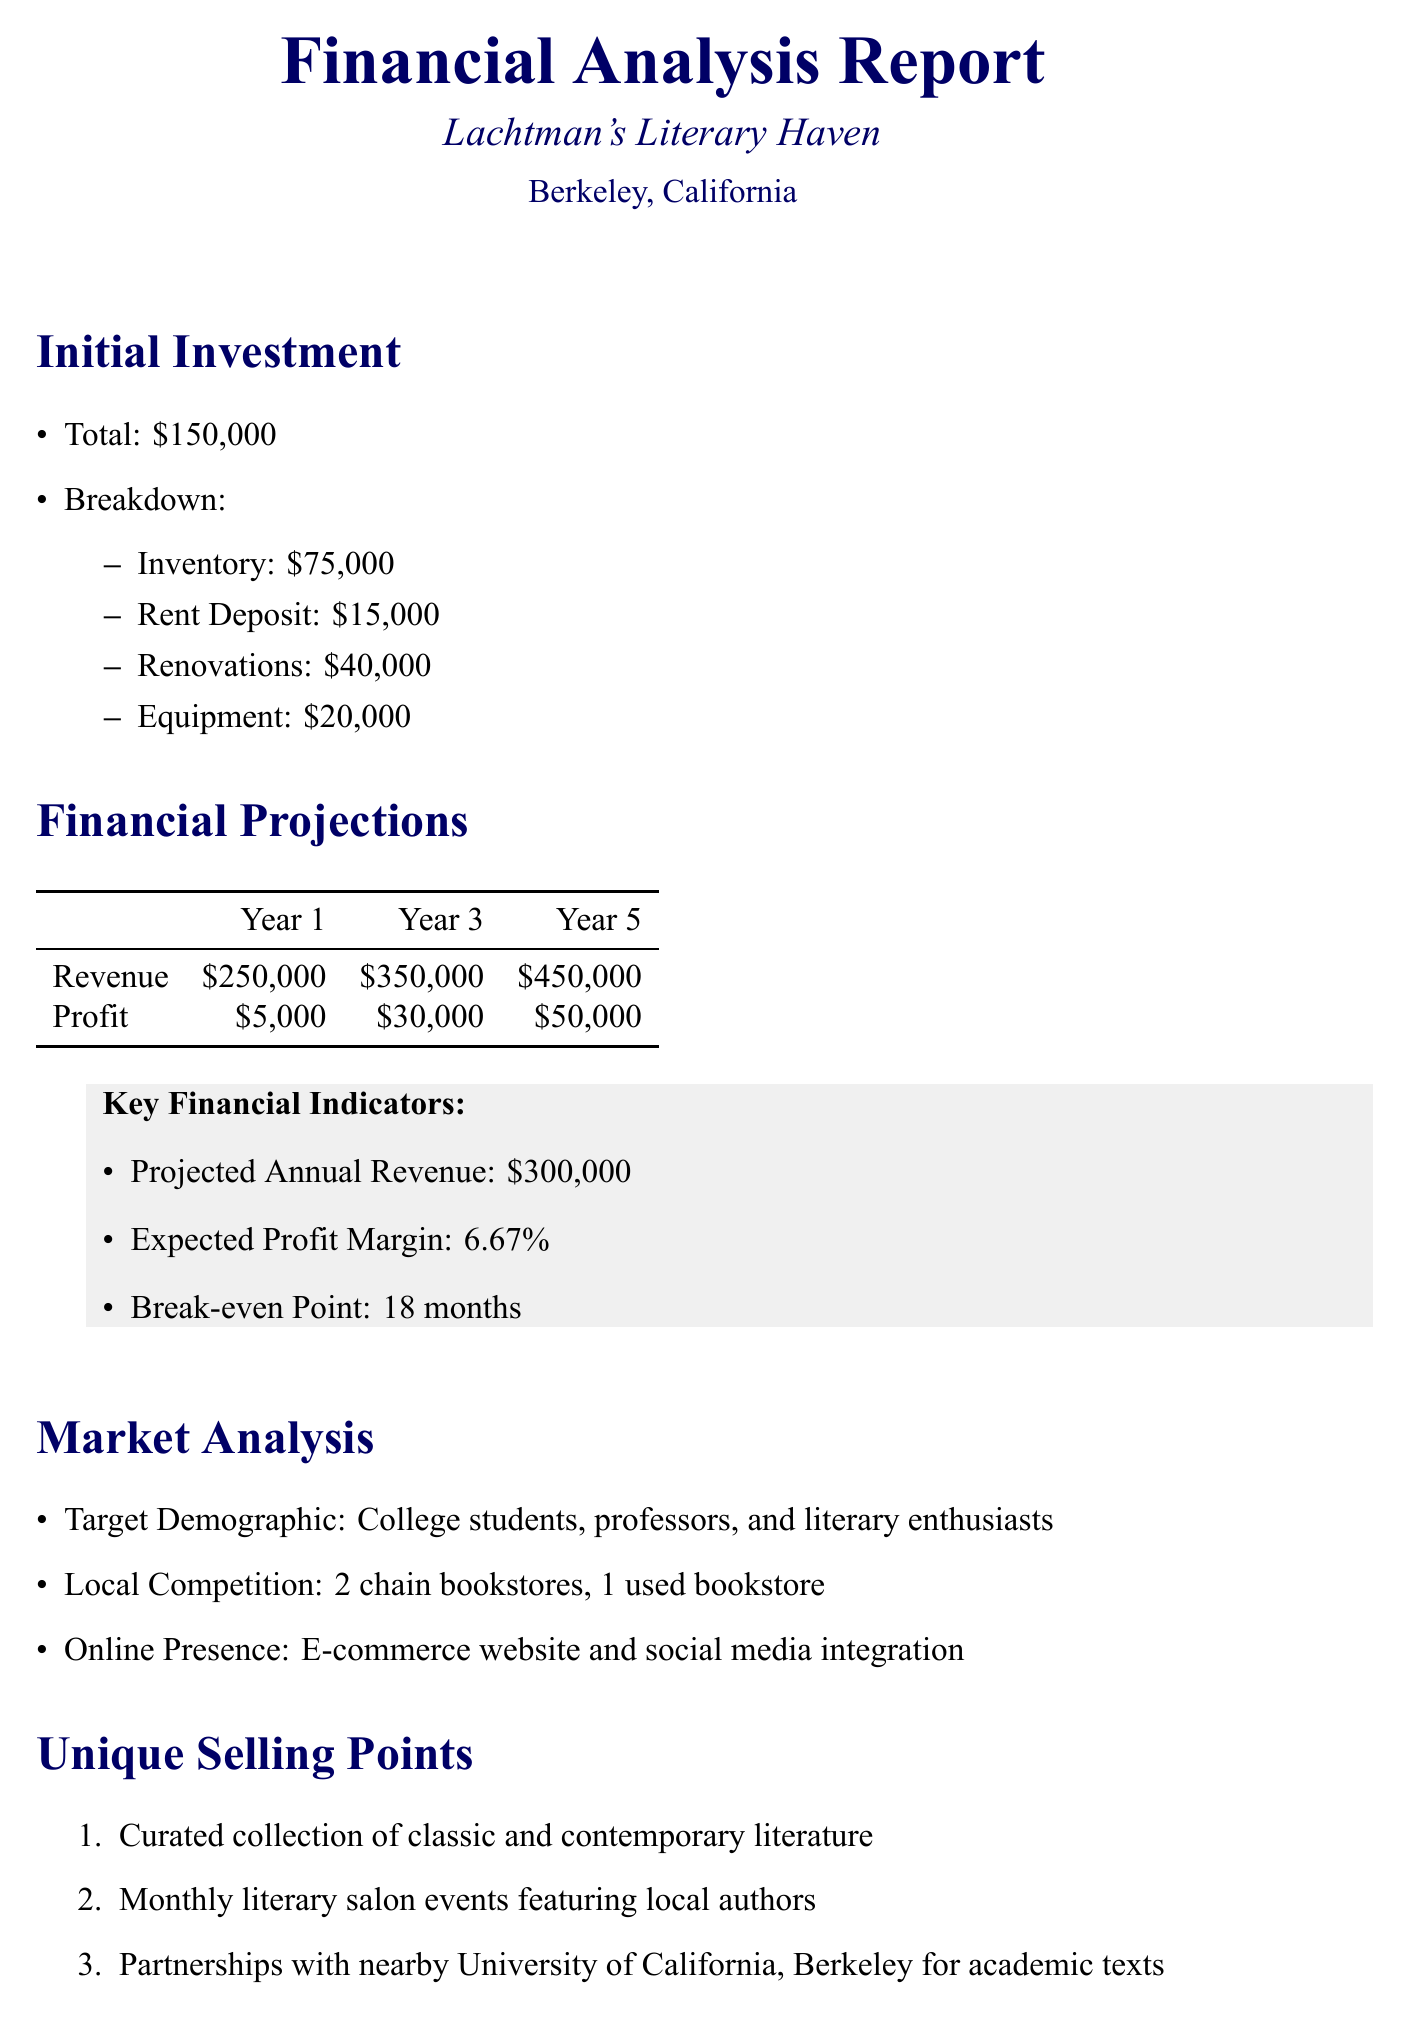what is the initial investment amount? The initial investment amount is stated clearly in the "Initial Investment" section of the document.
Answer: $150,000 what are the projected annual expenses for salaries? The projected annual expenses include specific breakdowns, found within the "projected_annual_expenses" section.
Answer: $120,000 how long is the break-even point? The break-even point is an important financial metric mentioned in the document under "Key Financial Indicators."
Answer: 18 months who is the target demographic? The target demographic is detailed in the "Market Analysis" section, which highlights the audience for the bookstore.
Answer: College students, professors, and literary enthusiasts what is one potential risk mentioned in the document? Potential risks are outlined in their own section, providing insights into challenges the bookstore may face.
Answer: Increasing competition from e-books and online retailers what is the profit for year 3? The profit for year 3 is part of the financial projections, which are presented in the document.
Answer: $30,000 name a unique selling point of the bookstore. The unique selling points are specifically listed in their section, emphasizing what makes the bookstore special.
Answer: Curated collection of classic and contemporary literature what is the projected annual revenue? The projected annual revenue is provided as a key financial indicator in the document.
Answer: $300,000 